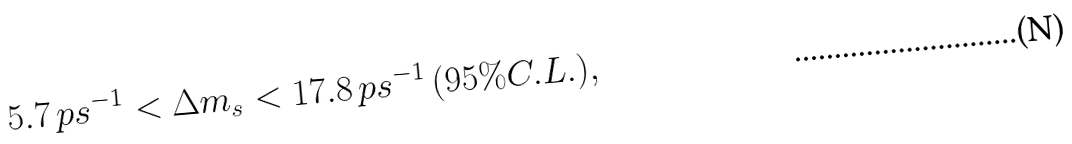Convert formula to latex. <formula><loc_0><loc_0><loc_500><loc_500>5 . 7 \, p s ^ { - 1 } < \Delta m _ { s } < 1 7 . 8 \, p s ^ { - 1 } \, ( 9 5 \% C . L . ) ,</formula> 